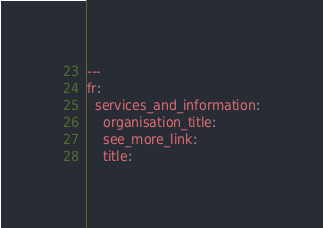<code> <loc_0><loc_0><loc_500><loc_500><_YAML_>---
fr:
  services_and_information:
    organisation_title:
    see_more_link:
    title:
</code> 